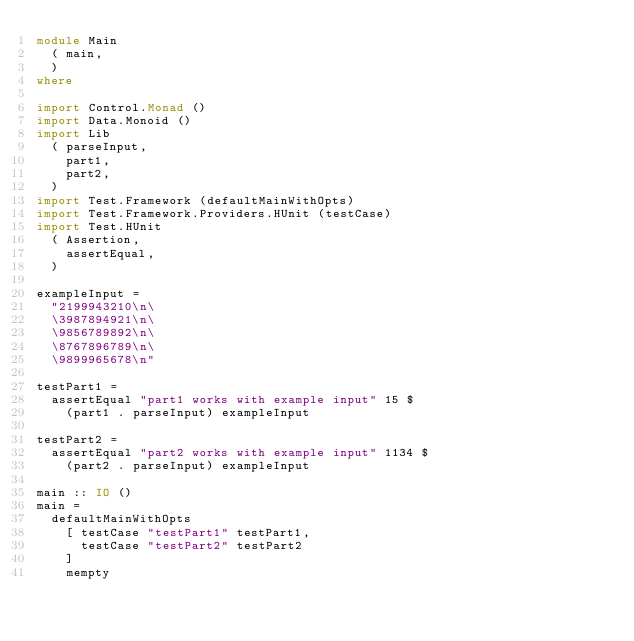<code> <loc_0><loc_0><loc_500><loc_500><_Haskell_>module Main
  ( main,
  )
where

import Control.Monad ()
import Data.Monoid ()
import Lib
  ( parseInput,
    part1,
    part2,
  )
import Test.Framework (defaultMainWithOpts)
import Test.Framework.Providers.HUnit (testCase)
import Test.HUnit
  ( Assertion,
    assertEqual,
  )

exampleInput =
  "2199943210\n\
  \3987894921\n\
  \9856789892\n\
  \8767896789\n\
  \9899965678\n"

testPart1 =
  assertEqual "part1 works with example input" 15 $
    (part1 . parseInput) exampleInput

testPart2 =
  assertEqual "part2 works with example input" 1134 $
    (part2 . parseInput) exampleInput

main :: IO ()
main =
  defaultMainWithOpts
    [ testCase "testPart1" testPart1,
      testCase "testPart2" testPart2
    ]
    mempty
</code> 